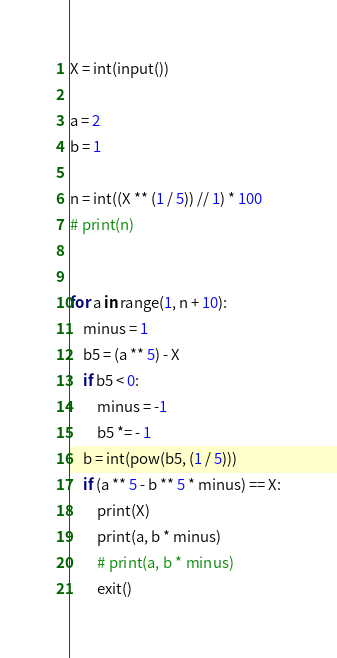Convert code to text. <code><loc_0><loc_0><loc_500><loc_500><_Python_>X = int(input())

a = 2
b = 1

n = int((X ** (1 / 5)) // 1) * 100
# print(n)


for a in range(1, n + 10):
    minus = 1
    b5 = (a ** 5) - X
    if b5 < 0:
        minus = -1
        b5 *= - 1
    b = int(pow(b5, (1 / 5)))
    if (a ** 5 - b ** 5 * minus) == X:
        print(X)
        print(a, b * minus)
        # print(a, b * minus)
        exit()

</code> 